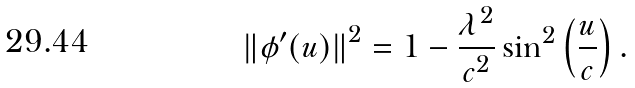Convert formula to latex. <formula><loc_0><loc_0><loc_500><loc_500>\left \| \phi ^ { \prime } ( u ) \right \| ^ { 2 } = 1 - \frac { \lambda ^ { 2 } } { c ^ { 2 } } \sin ^ { 2 } \left ( \frac { u } { c } \right ) .</formula> 